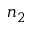Convert formula to latex. <formula><loc_0><loc_0><loc_500><loc_500>n _ { 2 }</formula> 